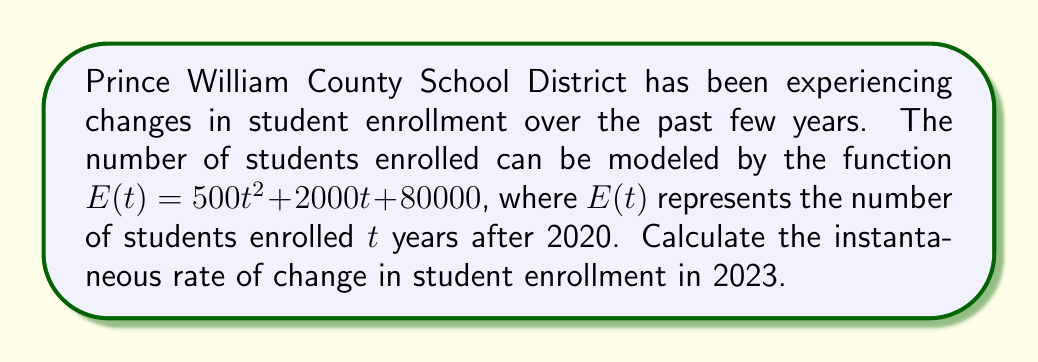Can you solve this math problem? To solve this problem, we need to follow these steps:

1) The instantaneous rate of change is given by the derivative of the function at a specific point. So, we need to find $E'(t)$.

2) To find $E'(t)$, we differentiate $E(t)$ with respect to $t$:

   $E'(t) = \frac{d}{dt}(500t^2 + 2000t + 80000)$
   $E'(t) = 1000t + 2000$

3) Now, we need to find the value of $t$ for 2023. Since our function starts at 2020, 2023 is 3 years after the start point. So, $t = 3$.

4) We can now calculate the instantaneous rate of change by evaluating $E'(3)$:

   $E'(3) = 1000(3) + 2000$
   $E'(3) = 3000 + 2000 = 5000$

Therefore, the instantaneous rate of change in student enrollment in 2023 is 5000 students per year.
Answer: 5000 students per year 